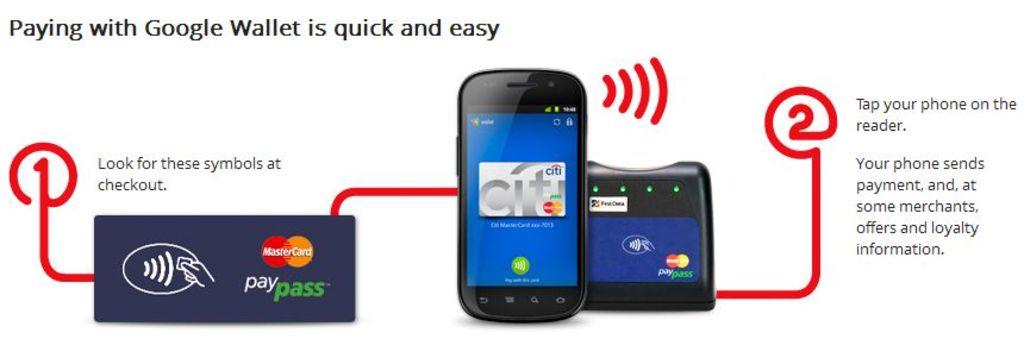Is paying with google wallet quick and easy?
Give a very brief answer. Yes. 